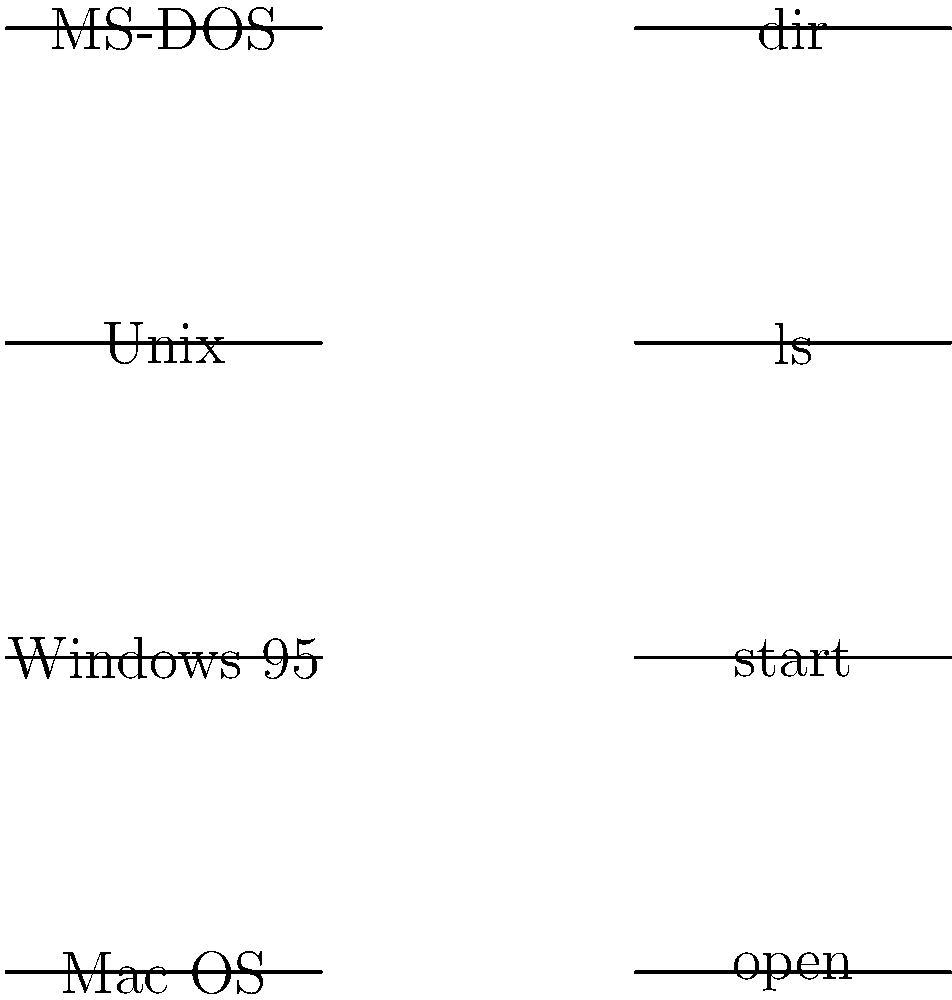Match the command-line interfaces to their respective operating systems. Which command is associated with the Unix operating system? To answer this question, let's analyze each command and its corresponding operating system:

1. "dir": This is the command used in MS-DOS and early Windows systems to list directory contents.

2. "ls": This is the Unix command used to list directory contents. It's also used in Unix-like systems such as Linux and macOS.

3. "start": This is a Windows command used to open a file or start a program.

4. "open": This is a command used in Mac OS to open files or applications.

Given the options and the question asking specifically about the Unix operating system, we can deduce that the correct answer is "ls". This command is fundamental to Unix and its derivatives, used for listing directory contents in a way that's distinct from the MS-DOS/Windows "dir" command.
Answer: ls 